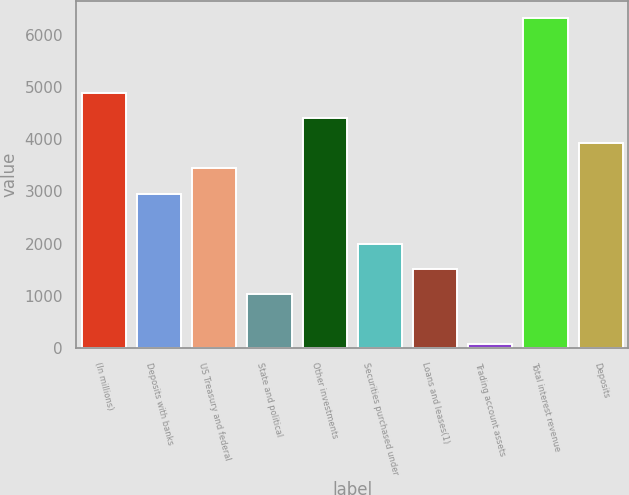<chart> <loc_0><loc_0><loc_500><loc_500><bar_chart><fcel>(In millions)<fcel>Deposits with banks<fcel>US Treasury and federal<fcel>State and political<fcel>Other investments<fcel>Securities purchased under<fcel>Loans and leases(1)<fcel>Trading account assets<fcel>Total interest revenue<fcel>Deposits<nl><fcel>4879<fcel>2958.6<fcel>3438.7<fcel>1038.2<fcel>4398.9<fcel>1998.4<fcel>1518.3<fcel>78<fcel>6319.3<fcel>3918.8<nl></chart> 